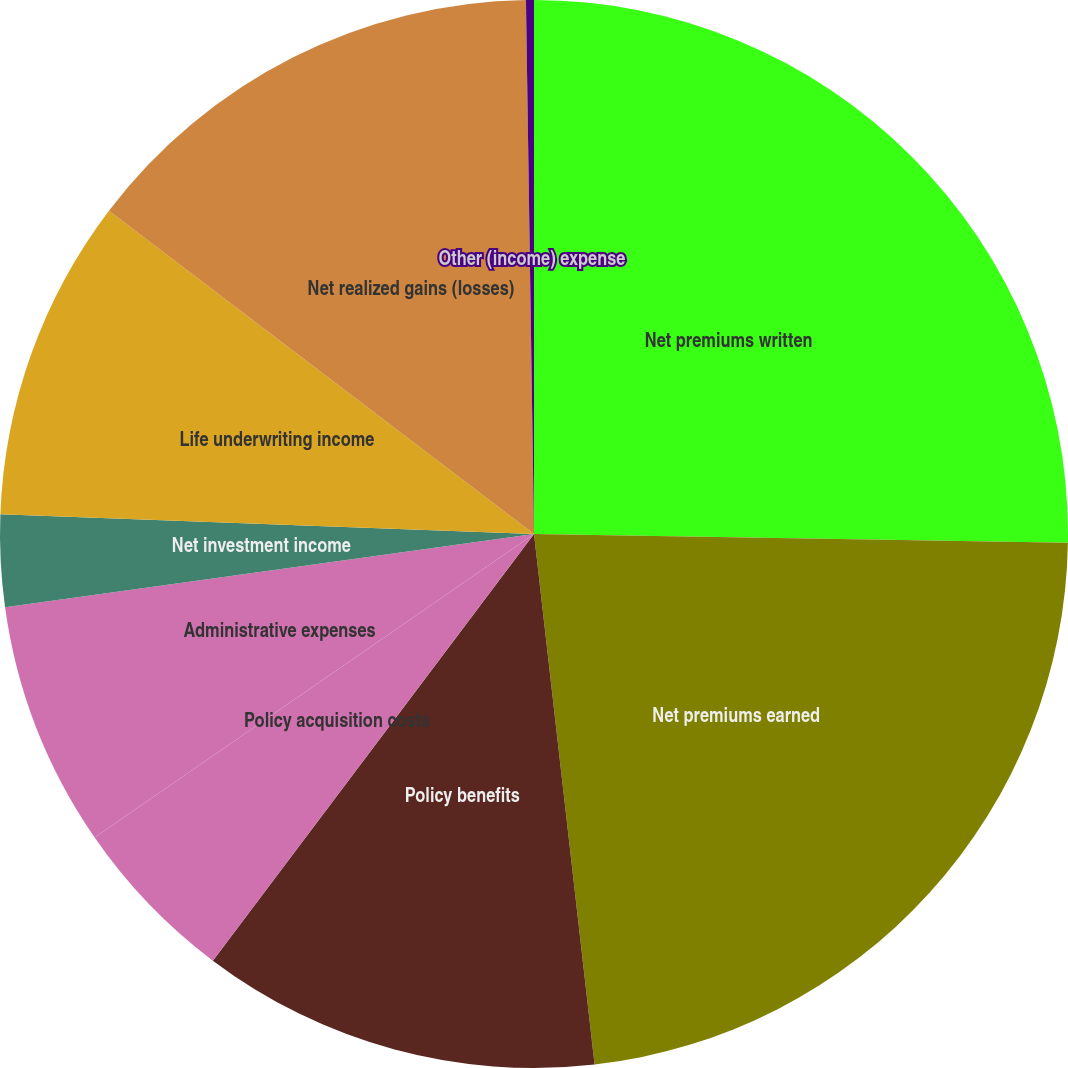Convert chart. <chart><loc_0><loc_0><loc_500><loc_500><pie_chart><fcel>Net premiums written<fcel>Net premiums earned<fcel>Policy benefits<fcel>Policy acquisition costs<fcel>Administrative expenses<fcel>Net investment income<fcel>Life underwriting income<fcel>Net realized gains (losses)<fcel>Other (income) expense<nl><fcel>25.26%<fcel>22.93%<fcel>12.08%<fcel>5.11%<fcel>7.43%<fcel>2.78%<fcel>9.76%<fcel>14.41%<fcel>0.24%<nl></chart> 